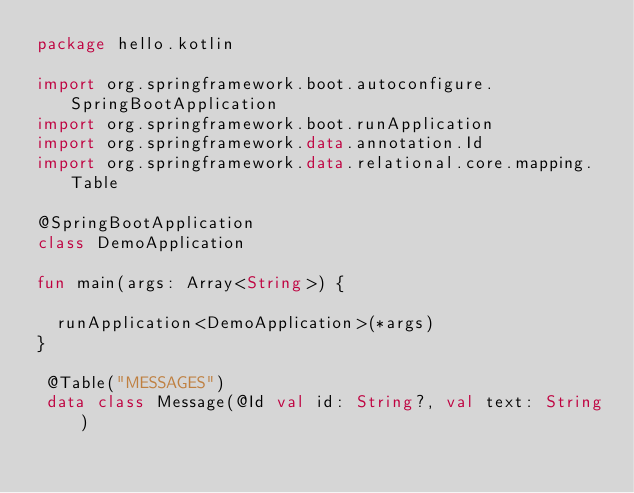<code> <loc_0><loc_0><loc_500><loc_500><_Kotlin_>package hello.kotlin

import org.springframework.boot.autoconfigure.SpringBootApplication
import org.springframework.boot.runApplication
import org.springframework.data.annotation.Id
import org.springframework.data.relational.core.mapping.Table

@SpringBootApplication
class DemoApplication

fun main(args: Array<String>) {

	runApplication<DemoApplication>(*args)
}

 @Table("MESSAGES")
 data class Message(@Id val id: String?, val text: String)
</code> 